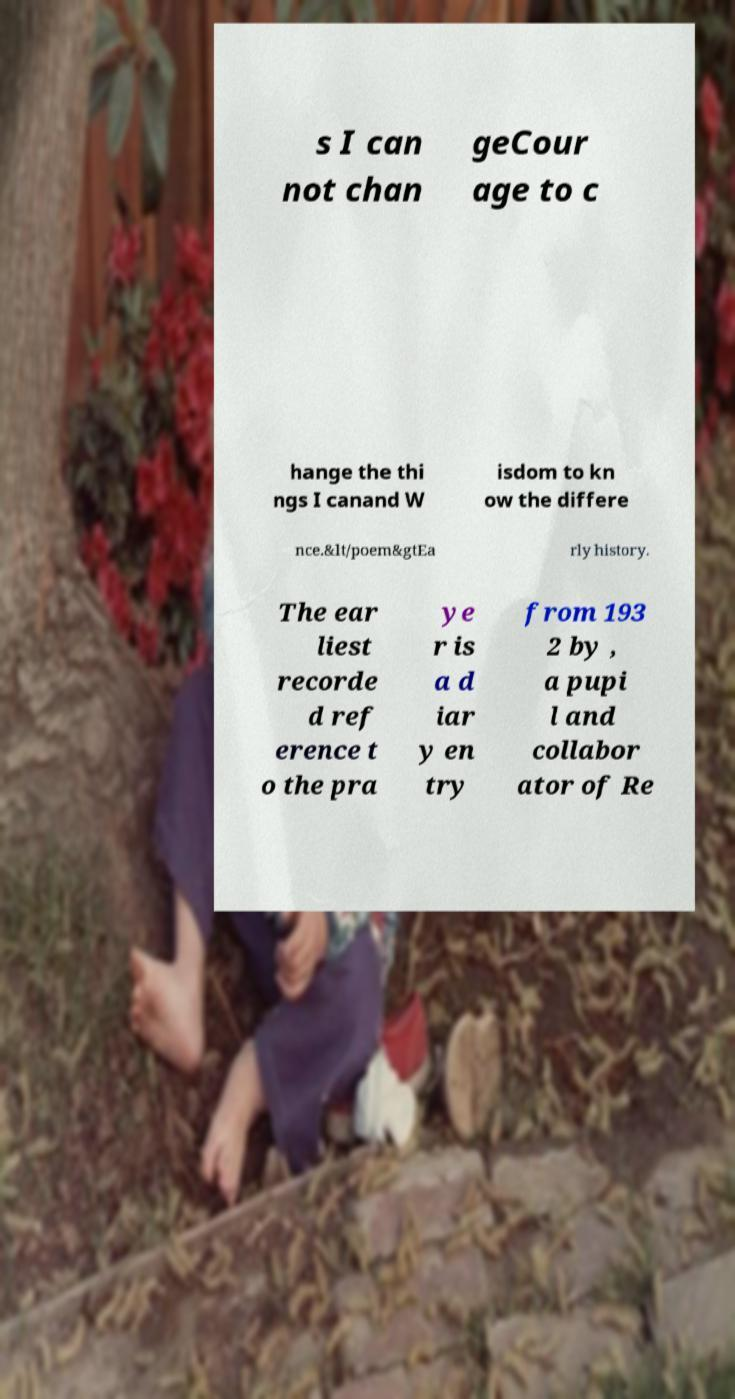For documentation purposes, I need the text within this image transcribed. Could you provide that? s I can not chan geCour age to c hange the thi ngs I canand W isdom to kn ow the differe nce.&lt/poem&gtEa rly history. The ear liest recorde d ref erence t o the pra ye r is a d iar y en try from 193 2 by , a pupi l and collabor ator of Re 